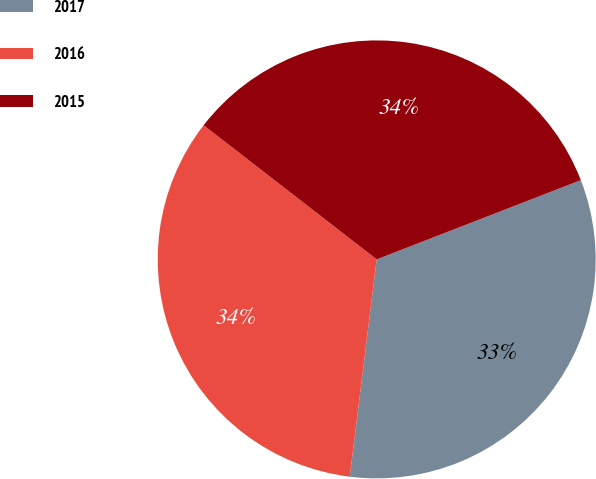Convert chart to OTSL. <chart><loc_0><loc_0><loc_500><loc_500><pie_chart><fcel>2017<fcel>2016<fcel>2015<nl><fcel>32.86%<fcel>33.53%<fcel>33.61%<nl></chart> 